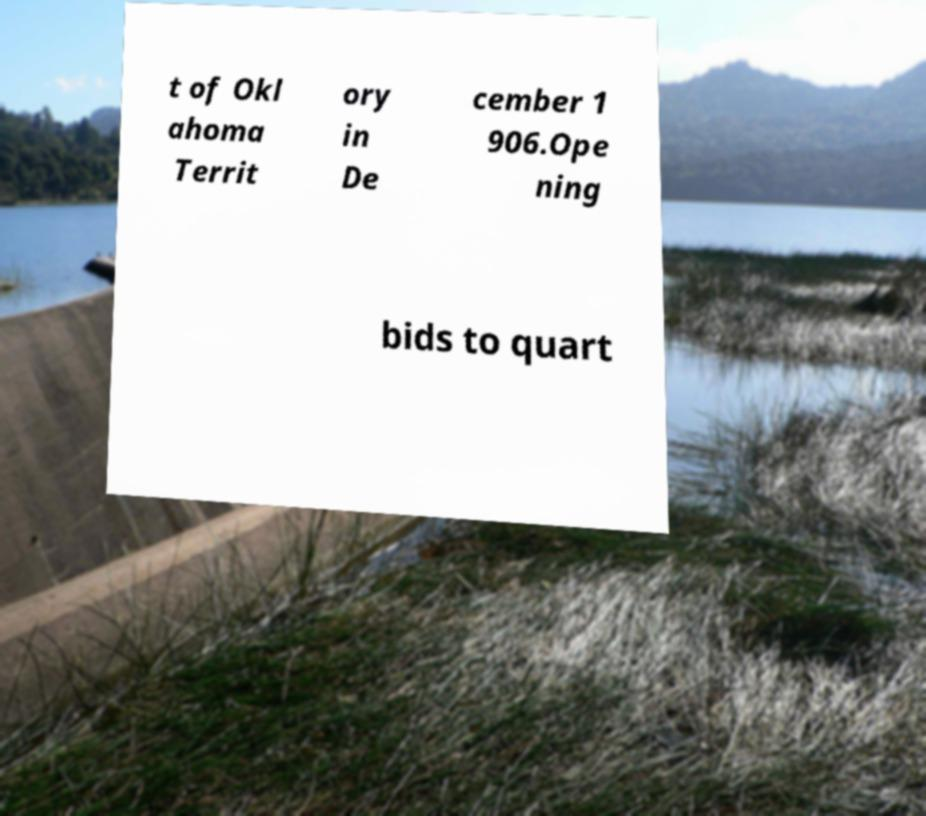For documentation purposes, I need the text within this image transcribed. Could you provide that? t of Okl ahoma Territ ory in De cember 1 906.Ope ning bids to quart 